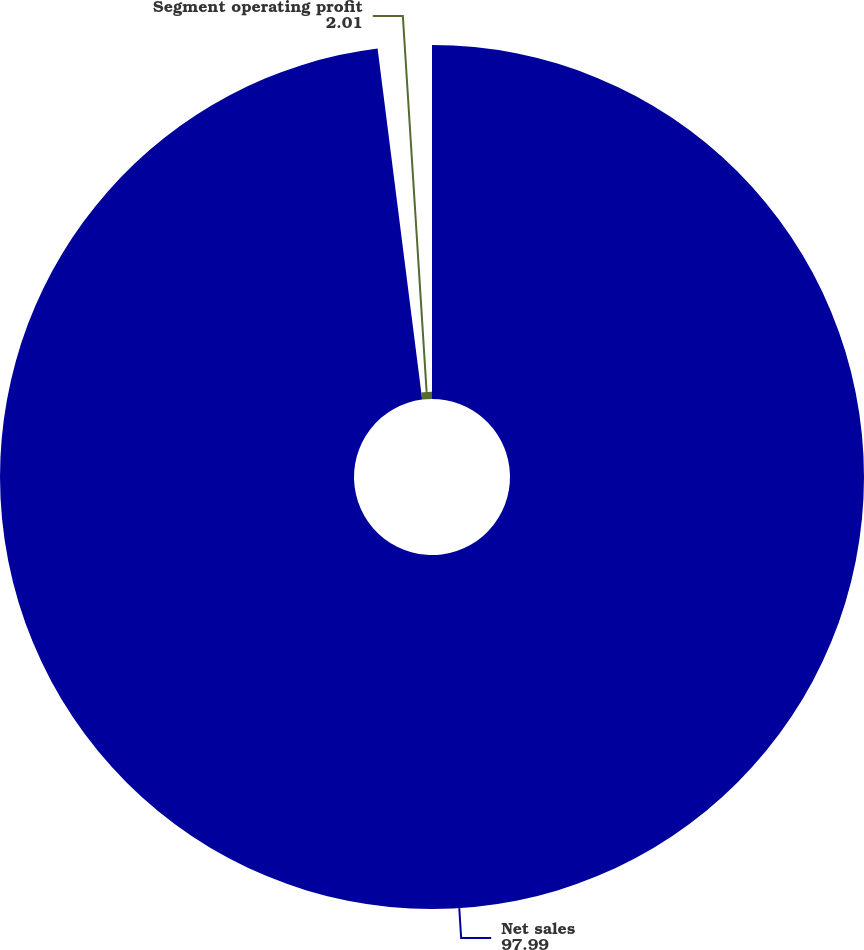Convert chart to OTSL. <chart><loc_0><loc_0><loc_500><loc_500><pie_chart><fcel>Net sales<fcel>Segment operating profit<nl><fcel>97.99%<fcel>2.01%<nl></chart> 